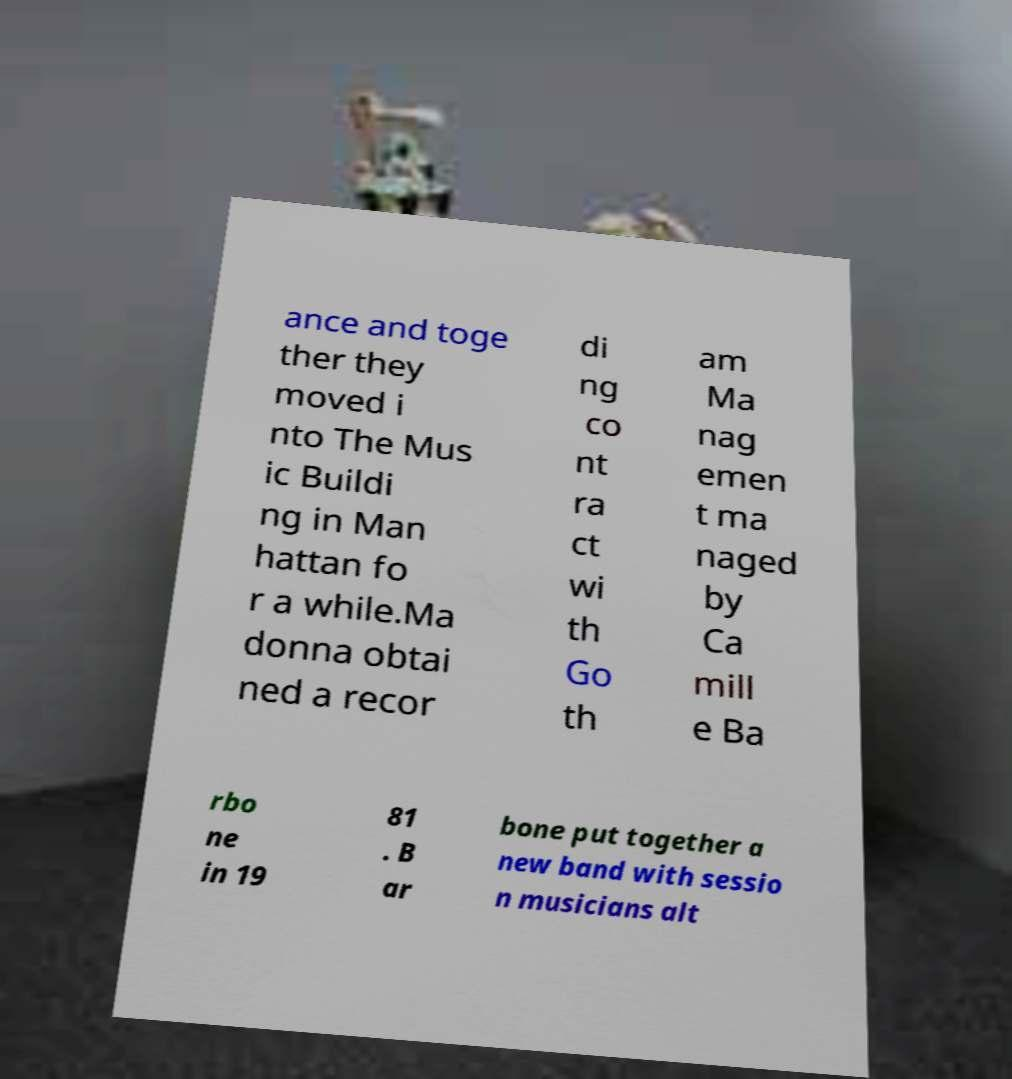I need the written content from this picture converted into text. Can you do that? ance and toge ther they moved i nto The Mus ic Buildi ng in Man hattan fo r a while.Ma donna obtai ned a recor di ng co nt ra ct wi th Go th am Ma nag emen t ma naged by Ca mill e Ba rbo ne in 19 81 . B ar bone put together a new band with sessio n musicians alt 